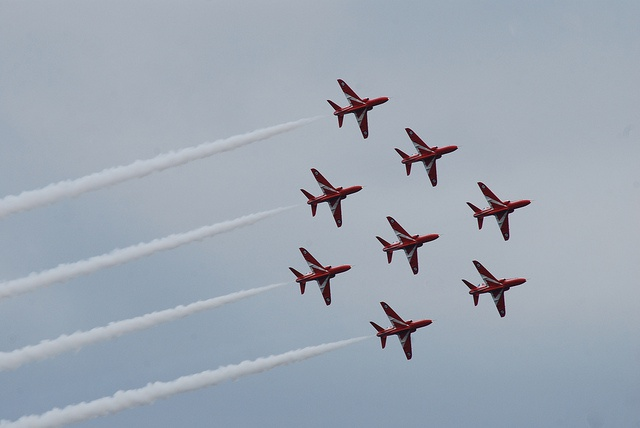Describe the objects in this image and their specific colors. I can see airplane in darkgray, black, maroon, and gray tones, airplane in darkgray, black, maroon, and gray tones, airplane in darkgray, black, maroon, and gray tones, airplane in darkgray, black, maroon, and gray tones, and airplane in darkgray, black, maroon, and gray tones in this image. 